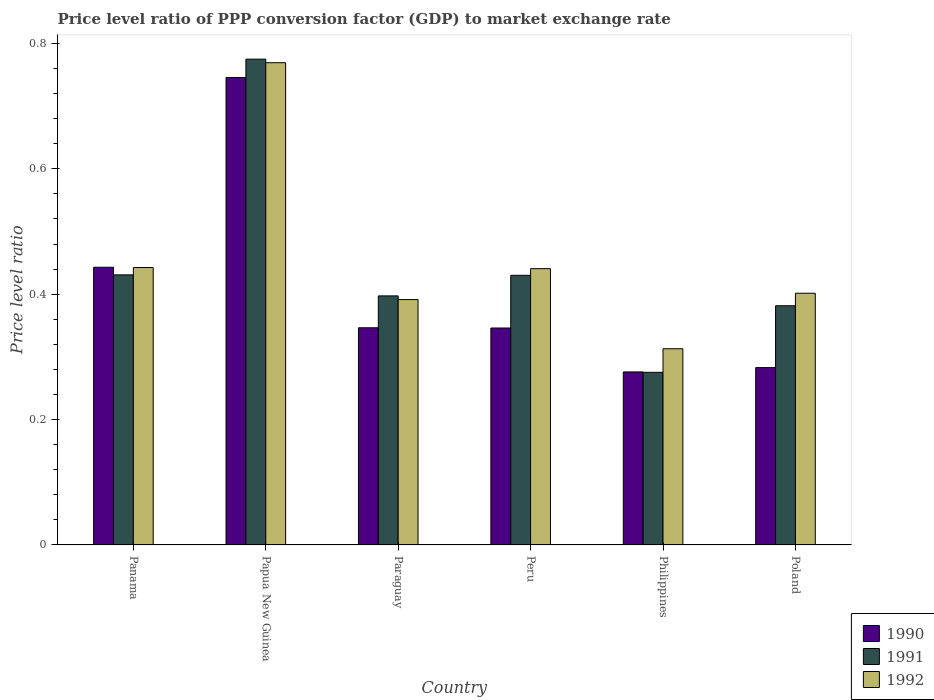How many bars are there on the 5th tick from the left?
Offer a terse response. 3. In how many cases, is the number of bars for a given country not equal to the number of legend labels?
Give a very brief answer. 0. What is the price level ratio in 1991 in Poland?
Keep it short and to the point. 0.38. Across all countries, what is the maximum price level ratio in 1990?
Offer a terse response. 0.75. Across all countries, what is the minimum price level ratio in 1991?
Your answer should be compact. 0.28. In which country was the price level ratio in 1991 maximum?
Keep it short and to the point. Papua New Guinea. In which country was the price level ratio in 1992 minimum?
Your response must be concise. Philippines. What is the total price level ratio in 1991 in the graph?
Your answer should be very brief. 2.69. What is the difference between the price level ratio in 1992 in Papua New Guinea and that in Poland?
Offer a terse response. 0.37. What is the difference between the price level ratio in 1992 in Philippines and the price level ratio in 1990 in Peru?
Your response must be concise. -0.03. What is the average price level ratio in 1992 per country?
Your answer should be compact. 0.46. What is the difference between the price level ratio of/in 1991 and price level ratio of/in 1990 in Poland?
Ensure brevity in your answer.  0.1. What is the ratio of the price level ratio in 1991 in Panama to that in Peru?
Make the answer very short. 1. Is the price level ratio in 1992 in Peru less than that in Poland?
Ensure brevity in your answer.  No. Is the difference between the price level ratio in 1991 in Panama and Paraguay greater than the difference between the price level ratio in 1990 in Panama and Paraguay?
Make the answer very short. No. What is the difference between the highest and the second highest price level ratio in 1990?
Ensure brevity in your answer.  0.3. What is the difference between the highest and the lowest price level ratio in 1990?
Give a very brief answer. 0.47. In how many countries, is the price level ratio in 1991 greater than the average price level ratio in 1991 taken over all countries?
Provide a short and direct response. 1. What does the 1st bar from the left in Philippines represents?
Your answer should be very brief. 1990. How many bars are there?
Your response must be concise. 18. Are all the bars in the graph horizontal?
Ensure brevity in your answer.  No. How many countries are there in the graph?
Give a very brief answer. 6. What is the difference between two consecutive major ticks on the Y-axis?
Offer a terse response. 0.2. Are the values on the major ticks of Y-axis written in scientific E-notation?
Make the answer very short. No. Does the graph contain grids?
Provide a succinct answer. No. Where does the legend appear in the graph?
Give a very brief answer. Bottom right. How are the legend labels stacked?
Offer a terse response. Vertical. What is the title of the graph?
Make the answer very short. Price level ratio of PPP conversion factor (GDP) to market exchange rate. What is the label or title of the Y-axis?
Make the answer very short. Price level ratio. What is the Price level ratio of 1990 in Panama?
Ensure brevity in your answer.  0.44. What is the Price level ratio of 1991 in Panama?
Offer a terse response. 0.43. What is the Price level ratio of 1992 in Panama?
Your answer should be compact. 0.44. What is the Price level ratio of 1990 in Papua New Guinea?
Offer a terse response. 0.75. What is the Price level ratio in 1991 in Papua New Guinea?
Offer a very short reply. 0.77. What is the Price level ratio in 1992 in Papua New Guinea?
Provide a short and direct response. 0.77. What is the Price level ratio of 1990 in Paraguay?
Offer a very short reply. 0.35. What is the Price level ratio of 1991 in Paraguay?
Your answer should be very brief. 0.4. What is the Price level ratio of 1992 in Paraguay?
Provide a succinct answer. 0.39. What is the Price level ratio in 1990 in Peru?
Keep it short and to the point. 0.35. What is the Price level ratio of 1991 in Peru?
Offer a very short reply. 0.43. What is the Price level ratio of 1992 in Peru?
Your answer should be compact. 0.44. What is the Price level ratio in 1990 in Philippines?
Offer a very short reply. 0.28. What is the Price level ratio of 1991 in Philippines?
Provide a succinct answer. 0.28. What is the Price level ratio of 1992 in Philippines?
Give a very brief answer. 0.31. What is the Price level ratio of 1990 in Poland?
Keep it short and to the point. 0.28. What is the Price level ratio in 1991 in Poland?
Your answer should be compact. 0.38. What is the Price level ratio in 1992 in Poland?
Offer a terse response. 0.4. Across all countries, what is the maximum Price level ratio in 1990?
Give a very brief answer. 0.75. Across all countries, what is the maximum Price level ratio of 1991?
Your response must be concise. 0.77. Across all countries, what is the maximum Price level ratio of 1992?
Give a very brief answer. 0.77. Across all countries, what is the minimum Price level ratio in 1990?
Your response must be concise. 0.28. Across all countries, what is the minimum Price level ratio in 1991?
Give a very brief answer. 0.28. Across all countries, what is the minimum Price level ratio in 1992?
Make the answer very short. 0.31. What is the total Price level ratio of 1990 in the graph?
Make the answer very short. 2.44. What is the total Price level ratio of 1991 in the graph?
Offer a terse response. 2.69. What is the total Price level ratio of 1992 in the graph?
Your answer should be very brief. 2.76. What is the difference between the Price level ratio in 1990 in Panama and that in Papua New Guinea?
Provide a succinct answer. -0.3. What is the difference between the Price level ratio of 1991 in Panama and that in Papua New Guinea?
Give a very brief answer. -0.34. What is the difference between the Price level ratio in 1992 in Panama and that in Papua New Guinea?
Provide a succinct answer. -0.33. What is the difference between the Price level ratio in 1990 in Panama and that in Paraguay?
Your answer should be very brief. 0.1. What is the difference between the Price level ratio of 1991 in Panama and that in Paraguay?
Ensure brevity in your answer.  0.03. What is the difference between the Price level ratio in 1992 in Panama and that in Paraguay?
Offer a very short reply. 0.05. What is the difference between the Price level ratio of 1990 in Panama and that in Peru?
Provide a succinct answer. 0.1. What is the difference between the Price level ratio in 1991 in Panama and that in Peru?
Provide a succinct answer. 0. What is the difference between the Price level ratio in 1992 in Panama and that in Peru?
Your answer should be compact. 0. What is the difference between the Price level ratio in 1990 in Panama and that in Philippines?
Ensure brevity in your answer.  0.17. What is the difference between the Price level ratio in 1991 in Panama and that in Philippines?
Make the answer very short. 0.16. What is the difference between the Price level ratio in 1992 in Panama and that in Philippines?
Your answer should be compact. 0.13. What is the difference between the Price level ratio in 1990 in Panama and that in Poland?
Provide a short and direct response. 0.16. What is the difference between the Price level ratio of 1991 in Panama and that in Poland?
Keep it short and to the point. 0.05. What is the difference between the Price level ratio in 1992 in Panama and that in Poland?
Your answer should be very brief. 0.04. What is the difference between the Price level ratio in 1990 in Papua New Guinea and that in Paraguay?
Ensure brevity in your answer.  0.4. What is the difference between the Price level ratio of 1991 in Papua New Guinea and that in Paraguay?
Give a very brief answer. 0.38. What is the difference between the Price level ratio in 1992 in Papua New Guinea and that in Paraguay?
Offer a very short reply. 0.38. What is the difference between the Price level ratio of 1990 in Papua New Guinea and that in Peru?
Keep it short and to the point. 0.4. What is the difference between the Price level ratio of 1991 in Papua New Guinea and that in Peru?
Offer a very short reply. 0.34. What is the difference between the Price level ratio of 1992 in Papua New Guinea and that in Peru?
Keep it short and to the point. 0.33. What is the difference between the Price level ratio in 1990 in Papua New Guinea and that in Philippines?
Give a very brief answer. 0.47. What is the difference between the Price level ratio in 1991 in Papua New Guinea and that in Philippines?
Your answer should be very brief. 0.5. What is the difference between the Price level ratio of 1992 in Papua New Guinea and that in Philippines?
Keep it short and to the point. 0.46. What is the difference between the Price level ratio of 1990 in Papua New Guinea and that in Poland?
Make the answer very short. 0.46. What is the difference between the Price level ratio in 1991 in Papua New Guinea and that in Poland?
Ensure brevity in your answer.  0.39. What is the difference between the Price level ratio in 1992 in Papua New Guinea and that in Poland?
Offer a terse response. 0.37. What is the difference between the Price level ratio of 1991 in Paraguay and that in Peru?
Your answer should be very brief. -0.03. What is the difference between the Price level ratio in 1992 in Paraguay and that in Peru?
Offer a terse response. -0.05. What is the difference between the Price level ratio in 1990 in Paraguay and that in Philippines?
Keep it short and to the point. 0.07. What is the difference between the Price level ratio of 1991 in Paraguay and that in Philippines?
Offer a terse response. 0.12. What is the difference between the Price level ratio in 1992 in Paraguay and that in Philippines?
Provide a succinct answer. 0.08. What is the difference between the Price level ratio of 1990 in Paraguay and that in Poland?
Give a very brief answer. 0.06. What is the difference between the Price level ratio in 1991 in Paraguay and that in Poland?
Provide a succinct answer. 0.02. What is the difference between the Price level ratio of 1992 in Paraguay and that in Poland?
Give a very brief answer. -0.01. What is the difference between the Price level ratio in 1990 in Peru and that in Philippines?
Offer a very short reply. 0.07. What is the difference between the Price level ratio in 1991 in Peru and that in Philippines?
Offer a very short reply. 0.15. What is the difference between the Price level ratio of 1992 in Peru and that in Philippines?
Give a very brief answer. 0.13. What is the difference between the Price level ratio of 1990 in Peru and that in Poland?
Offer a very short reply. 0.06. What is the difference between the Price level ratio of 1991 in Peru and that in Poland?
Your answer should be very brief. 0.05. What is the difference between the Price level ratio in 1992 in Peru and that in Poland?
Provide a short and direct response. 0.04. What is the difference between the Price level ratio in 1990 in Philippines and that in Poland?
Make the answer very short. -0.01. What is the difference between the Price level ratio in 1991 in Philippines and that in Poland?
Make the answer very short. -0.11. What is the difference between the Price level ratio in 1992 in Philippines and that in Poland?
Your answer should be compact. -0.09. What is the difference between the Price level ratio in 1990 in Panama and the Price level ratio in 1991 in Papua New Guinea?
Your answer should be compact. -0.33. What is the difference between the Price level ratio of 1990 in Panama and the Price level ratio of 1992 in Papua New Guinea?
Offer a terse response. -0.33. What is the difference between the Price level ratio of 1991 in Panama and the Price level ratio of 1992 in Papua New Guinea?
Make the answer very short. -0.34. What is the difference between the Price level ratio in 1990 in Panama and the Price level ratio in 1991 in Paraguay?
Give a very brief answer. 0.05. What is the difference between the Price level ratio in 1990 in Panama and the Price level ratio in 1992 in Paraguay?
Your response must be concise. 0.05. What is the difference between the Price level ratio of 1991 in Panama and the Price level ratio of 1992 in Paraguay?
Offer a terse response. 0.04. What is the difference between the Price level ratio in 1990 in Panama and the Price level ratio in 1991 in Peru?
Provide a succinct answer. 0.01. What is the difference between the Price level ratio of 1990 in Panama and the Price level ratio of 1992 in Peru?
Your response must be concise. 0. What is the difference between the Price level ratio in 1991 in Panama and the Price level ratio in 1992 in Peru?
Offer a terse response. -0.01. What is the difference between the Price level ratio in 1990 in Panama and the Price level ratio in 1991 in Philippines?
Your answer should be compact. 0.17. What is the difference between the Price level ratio of 1990 in Panama and the Price level ratio of 1992 in Philippines?
Give a very brief answer. 0.13. What is the difference between the Price level ratio of 1991 in Panama and the Price level ratio of 1992 in Philippines?
Offer a very short reply. 0.12. What is the difference between the Price level ratio in 1990 in Panama and the Price level ratio in 1991 in Poland?
Your response must be concise. 0.06. What is the difference between the Price level ratio in 1990 in Panama and the Price level ratio in 1992 in Poland?
Provide a succinct answer. 0.04. What is the difference between the Price level ratio in 1991 in Panama and the Price level ratio in 1992 in Poland?
Keep it short and to the point. 0.03. What is the difference between the Price level ratio of 1990 in Papua New Guinea and the Price level ratio of 1991 in Paraguay?
Provide a short and direct response. 0.35. What is the difference between the Price level ratio in 1990 in Papua New Guinea and the Price level ratio in 1992 in Paraguay?
Your answer should be very brief. 0.35. What is the difference between the Price level ratio in 1991 in Papua New Guinea and the Price level ratio in 1992 in Paraguay?
Your answer should be compact. 0.38. What is the difference between the Price level ratio in 1990 in Papua New Guinea and the Price level ratio in 1991 in Peru?
Keep it short and to the point. 0.32. What is the difference between the Price level ratio of 1990 in Papua New Guinea and the Price level ratio of 1992 in Peru?
Ensure brevity in your answer.  0.3. What is the difference between the Price level ratio in 1991 in Papua New Guinea and the Price level ratio in 1992 in Peru?
Your answer should be very brief. 0.33. What is the difference between the Price level ratio of 1990 in Papua New Guinea and the Price level ratio of 1991 in Philippines?
Offer a very short reply. 0.47. What is the difference between the Price level ratio of 1990 in Papua New Guinea and the Price level ratio of 1992 in Philippines?
Provide a succinct answer. 0.43. What is the difference between the Price level ratio of 1991 in Papua New Guinea and the Price level ratio of 1992 in Philippines?
Ensure brevity in your answer.  0.46. What is the difference between the Price level ratio in 1990 in Papua New Guinea and the Price level ratio in 1991 in Poland?
Give a very brief answer. 0.36. What is the difference between the Price level ratio in 1990 in Papua New Guinea and the Price level ratio in 1992 in Poland?
Keep it short and to the point. 0.34. What is the difference between the Price level ratio in 1991 in Papua New Guinea and the Price level ratio in 1992 in Poland?
Keep it short and to the point. 0.37. What is the difference between the Price level ratio of 1990 in Paraguay and the Price level ratio of 1991 in Peru?
Provide a short and direct response. -0.08. What is the difference between the Price level ratio of 1990 in Paraguay and the Price level ratio of 1992 in Peru?
Offer a terse response. -0.09. What is the difference between the Price level ratio in 1991 in Paraguay and the Price level ratio in 1992 in Peru?
Make the answer very short. -0.04. What is the difference between the Price level ratio in 1990 in Paraguay and the Price level ratio in 1991 in Philippines?
Offer a terse response. 0.07. What is the difference between the Price level ratio of 1990 in Paraguay and the Price level ratio of 1992 in Philippines?
Give a very brief answer. 0.03. What is the difference between the Price level ratio in 1991 in Paraguay and the Price level ratio in 1992 in Philippines?
Ensure brevity in your answer.  0.08. What is the difference between the Price level ratio in 1990 in Paraguay and the Price level ratio in 1991 in Poland?
Your answer should be very brief. -0.04. What is the difference between the Price level ratio of 1990 in Paraguay and the Price level ratio of 1992 in Poland?
Give a very brief answer. -0.06. What is the difference between the Price level ratio in 1991 in Paraguay and the Price level ratio in 1992 in Poland?
Offer a very short reply. -0. What is the difference between the Price level ratio in 1990 in Peru and the Price level ratio in 1991 in Philippines?
Your response must be concise. 0.07. What is the difference between the Price level ratio in 1990 in Peru and the Price level ratio in 1992 in Philippines?
Ensure brevity in your answer.  0.03. What is the difference between the Price level ratio of 1991 in Peru and the Price level ratio of 1992 in Philippines?
Provide a succinct answer. 0.12. What is the difference between the Price level ratio in 1990 in Peru and the Price level ratio in 1991 in Poland?
Make the answer very short. -0.04. What is the difference between the Price level ratio of 1990 in Peru and the Price level ratio of 1992 in Poland?
Your answer should be compact. -0.06. What is the difference between the Price level ratio of 1991 in Peru and the Price level ratio of 1992 in Poland?
Provide a succinct answer. 0.03. What is the difference between the Price level ratio of 1990 in Philippines and the Price level ratio of 1991 in Poland?
Keep it short and to the point. -0.11. What is the difference between the Price level ratio of 1990 in Philippines and the Price level ratio of 1992 in Poland?
Provide a succinct answer. -0.13. What is the difference between the Price level ratio of 1991 in Philippines and the Price level ratio of 1992 in Poland?
Ensure brevity in your answer.  -0.13. What is the average Price level ratio of 1990 per country?
Ensure brevity in your answer.  0.41. What is the average Price level ratio of 1991 per country?
Your answer should be very brief. 0.45. What is the average Price level ratio of 1992 per country?
Ensure brevity in your answer.  0.46. What is the difference between the Price level ratio of 1990 and Price level ratio of 1991 in Panama?
Ensure brevity in your answer.  0.01. What is the difference between the Price level ratio in 1990 and Price level ratio in 1992 in Panama?
Your answer should be compact. 0. What is the difference between the Price level ratio in 1991 and Price level ratio in 1992 in Panama?
Your answer should be compact. -0.01. What is the difference between the Price level ratio of 1990 and Price level ratio of 1991 in Papua New Guinea?
Offer a very short reply. -0.03. What is the difference between the Price level ratio in 1990 and Price level ratio in 1992 in Papua New Guinea?
Provide a short and direct response. -0.02. What is the difference between the Price level ratio in 1991 and Price level ratio in 1992 in Papua New Guinea?
Provide a succinct answer. 0.01. What is the difference between the Price level ratio of 1990 and Price level ratio of 1991 in Paraguay?
Keep it short and to the point. -0.05. What is the difference between the Price level ratio in 1990 and Price level ratio in 1992 in Paraguay?
Your response must be concise. -0.04. What is the difference between the Price level ratio in 1991 and Price level ratio in 1992 in Paraguay?
Your answer should be very brief. 0.01. What is the difference between the Price level ratio of 1990 and Price level ratio of 1991 in Peru?
Offer a terse response. -0.08. What is the difference between the Price level ratio of 1990 and Price level ratio of 1992 in Peru?
Give a very brief answer. -0.09. What is the difference between the Price level ratio of 1991 and Price level ratio of 1992 in Peru?
Your response must be concise. -0.01. What is the difference between the Price level ratio of 1990 and Price level ratio of 1991 in Philippines?
Offer a very short reply. 0. What is the difference between the Price level ratio in 1990 and Price level ratio in 1992 in Philippines?
Ensure brevity in your answer.  -0.04. What is the difference between the Price level ratio in 1991 and Price level ratio in 1992 in Philippines?
Offer a terse response. -0.04. What is the difference between the Price level ratio of 1990 and Price level ratio of 1991 in Poland?
Ensure brevity in your answer.  -0.1. What is the difference between the Price level ratio in 1990 and Price level ratio in 1992 in Poland?
Your answer should be compact. -0.12. What is the difference between the Price level ratio of 1991 and Price level ratio of 1992 in Poland?
Offer a terse response. -0.02. What is the ratio of the Price level ratio in 1990 in Panama to that in Papua New Guinea?
Offer a very short reply. 0.59. What is the ratio of the Price level ratio of 1991 in Panama to that in Papua New Guinea?
Keep it short and to the point. 0.56. What is the ratio of the Price level ratio in 1992 in Panama to that in Papua New Guinea?
Keep it short and to the point. 0.58. What is the ratio of the Price level ratio in 1990 in Panama to that in Paraguay?
Offer a very short reply. 1.28. What is the ratio of the Price level ratio of 1991 in Panama to that in Paraguay?
Give a very brief answer. 1.08. What is the ratio of the Price level ratio in 1992 in Panama to that in Paraguay?
Make the answer very short. 1.13. What is the ratio of the Price level ratio of 1990 in Panama to that in Peru?
Your response must be concise. 1.28. What is the ratio of the Price level ratio of 1992 in Panama to that in Peru?
Your answer should be very brief. 1. What is the ratio of the Price level ratio of 1990 in Panama to that in Philippines?
Give a very brief answer. 1.61. What is the ratio of the Price level ratio in 1991 in Panama to that in Philippines?
Give a very brief answer. 1.56. What is the ratio of the Price level ratio in 1992 in Panama to that in Philippines?
Offer a terse response. 1.41. What is the ratio of the Price level ratio in 1990 in Panama to that in Poland?
Your answer should be very brief. 1.57. What is the ratio of the Price level ratio in 1991 in Panama to that in Poland?
Ensure brevity in your answer.  1.13. What is the ratio of the Price level ratio in 1992 in Panama to that in Poland?
Offer a terse response. 1.1. What is the ratio of the Price level ratio of 1990 in Papua New Guinea to that in Paraguay?
Ensure brevity in your answer.  2.15. What is the ratio of the Price level ratio of 1991 in Papua New Guinea to that in Paraguay?
Give a very brief answer. 1.95. What is the ratio of the Price level ratio in 1992 in Papua New Guinea to that in Paraguay?
Your response must be concise. 1.97. What is the ratio of the Price level ratio of 1990 in Papua New Guinea to that in Peru?
Keep it short and to the point. 2.15. What is the ratio of the Price level ratio in 1991 in Papua New Guinea to that in Peru?
Offer a very short reply. 1.8. What is the ratio of the Price level ratio of 1992 in Papua New Guinea to that in Peru?
Your answer should be compact. 1.75. What is the ratio of the Price level ratio in 1990 in Papua New Guinea to that in Philippines?
Provide a succinct answer. 2.7. What is the ratio of the Price level ratio of 1991 in Papua New Guinea to that in Philippines?
Your answer should be very brief. 2.81. What is the ratio of the Price level ratio in 1992 in Papua New Guinea to that in Philippines?
Keep it short and to the point. 2.46. What is the ratio of the Price level ratio in 1990 in Papua New Guinea to that in Poland?
Ensure brevity in your answer.  2.64. What is the ratio of the Price level ratio in 1991 in Papua New Guinea to that in Poland?
Your answer should be compact. 2.03. What is the ratio of the Price level ratio in 1992 in Papua New Guinea to that in Poland?
Ensure brevity in your answer.  1.92. What is the ratio of the Price level ratio of 1990 in Paraguay to that in Peru?
Your answer should be very brief. 1. What is the ratio of the Price level ratio in 1991 in Paraguay to that in Peru?
Make the answer very short. 0.92. What is the ratio of the Price level ratio in 1992 in Paraguay to that in Peru?
Your answer should be very brief. 0.89. What is the ratio of the Price level ratio of 1990 in Paraguay to that in Philippines?
Give a very brief answer. 1.26. What is the ratio of the Price level ratio in 1991 in Paraguay to that in Philippines?
Keep it short and to the point. 1.44. What is the ratio of the Price level ratio in 1992 in Paraguay to that in Philippines?
Offer a very short reply. 1.25. What is the ratio of the Price level ratio of 1990 in Paraguay to that in Poland?
Ensure brevity in your answer.  1.22. What is the ratio of the Price level ratio of 1991 in Paraguay to that in Poland?
Make the answer very short. 1.04. What is the ratio of the Price level ratio in 1992 in Paraguay to that in Poland?
Ensure brevity in your answer.  0.97. What is the ratio of the Price level ratio of 1990 in Peru to that in Philippines?
Your answer should be very brief. 1.25. What is the ratio of the Price level ratio in 1991 in Peru to that in Philippines?
Make the answer very short. 1.56. What is the ratio of the Price level ratio of 1992 in Peru to that in Philippines?
Your response must be concise. 1.41. What is the ratio of the Price level ratio of 1990 in Peru to that in Poland?
Your answer should be compact. 1.22. What is the ratio of the Price level ratio of 1991 in Peru to that in Poland?
Your answer should be compact. 1.13. What is the ratio of the Price level ratio of 1992 in Peru to that in Poland?
Make the answer very short. 1.1. What is the ratio of the Price level ratio in 1990 in Philippines to that in Poland?
Keep it short and to the point. 0.98. What is the ratio of the Price level ratio in 1991 in Philippines to that in Poland?
Offer a terse response. 0.72. What is the ratio of the Price level ratio in 1992 in Philippines to that in Poland?
Make the answer very short. 0.78. What is the difference between the highest and the second highest Price level ratio of 1990?
Ensure brevity in your answer.  0.3. What is the difference between the highest and the second highest Price level ratio of 1991?
Offer a very short reply. 0.34. What is the difference between the highest and the second highest Price level ratio of 1992?
Provide a succinct answer. 0.33. What is the difference between the highest and the lowest Price level ratio in 1990?
Provide a short and direct response. 0.47. What is the difference between the highest and the lowest Price level ratio in 1991?
Offer a terse response. 0.5. What is the difference between the highest and the lowest Price level ratio in 1992?
Provide a short and direct response. 0.46. 